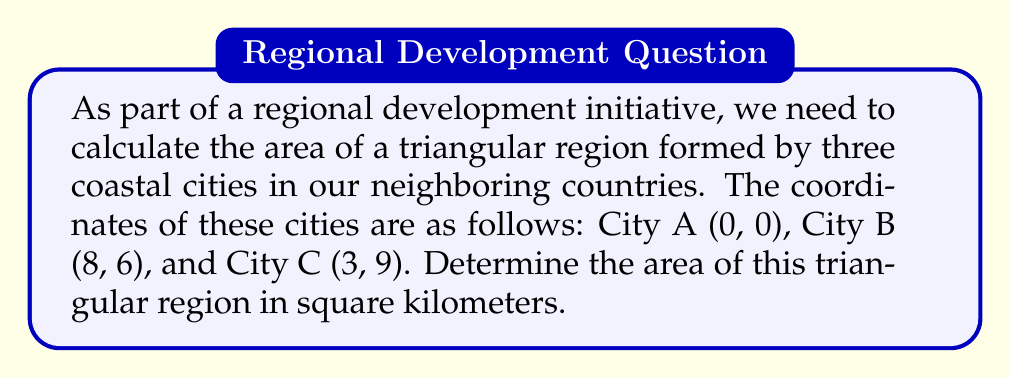Help me with this question. To find the area of the triangular region, we can use the formula for the area of a triangle given the coordinates of its vertices:

$$\text{Area} = \frac{1}{2}|x_1(y_2 - y_3) + x_2(y_3 - y_1) + x_3(y_1 - y_2)|$$

Where $(x_1, y_1)$, $(x_2, y_2)$, and $(x_3, y_3)$ are the coordinates of the three vertices.

Let's substitute the given coordinates:
$(x_1, y_1) = (0, 0)$
$(x_2, y_2) = (8, 6)$
$(x_3, y_3) = (3, 9)$

Now, let's calculate step by step:

1) $x_1(y_2 - y_3) = 0(6 - 9) = 0(-3) = 0$

2) $x_2(y_3 - y_1) = 8(9 - 0) = 8(9) = 72$

3) $x_3(y_1 - y_2) = 3(0 - 6) = 3(-6) = -18$

4) Sum these values: $0 + 72 + (-18) = 54$

5) Take the absolute value: $|54| = 54$

6) Multiply by $\frac{1}{2}$: $\frac{1}{2} \times 54 = 27$

Therefore, the area of the triangular region is 27 square kilometers.

[asy]
unitsize(10mm);
draw((0,0)--(8,6)--(3,9)--cycle);
dot((0,0)); dot((8,6)); dot((3,9));
label("A (0,0)", (0,0), SW);
label("B (8,6)", (8,6), SE);
label("C (3,9)", (3,9), N);
[/asy]
Answer: 27 sq km 